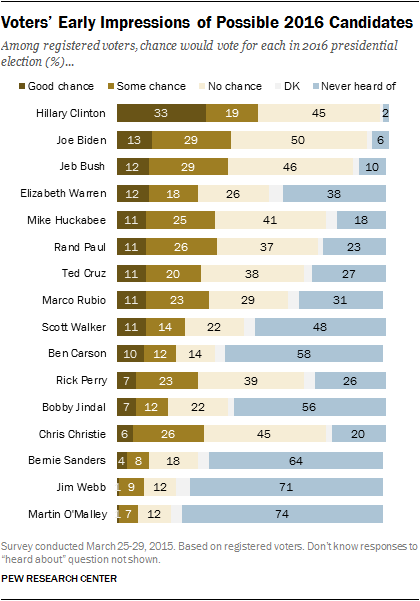Mention a couple of crucial points in this snapshot. The difference between the largest value of the white bar and the least value of the blue bar is 48. The white bar represents the value of DK... 